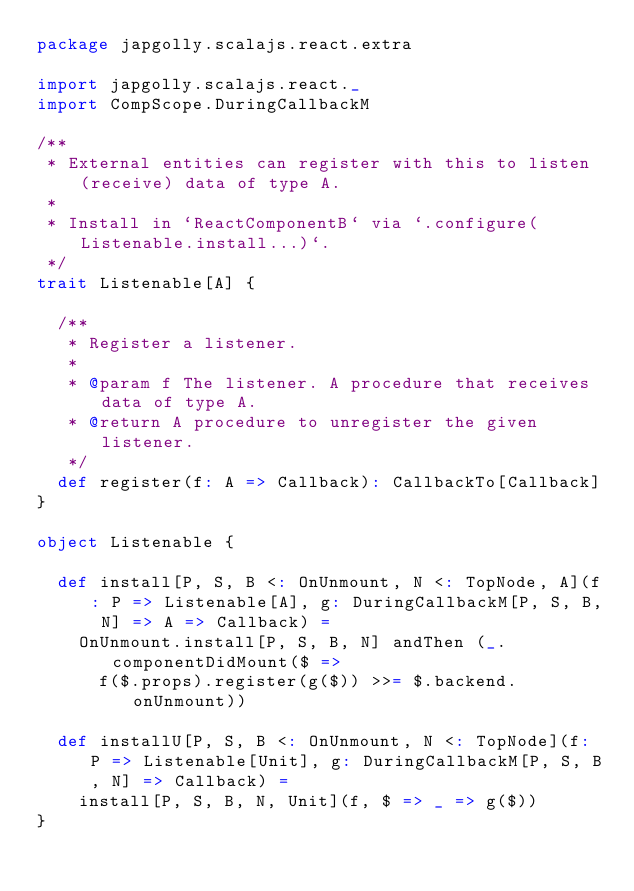Convert code to text. <code><loc_0><loc_0><loc_500><loc_500><_Scala_>package japgolly.scalajs.react.extra

import japgolly.scalajs.react._
import CompScope.DuringCallbackM

/**
 * External entities can register with this to listen (receive) data of type A.
 *
 * Install in `ReactComponentB` via `.configure(Listenable.install...)`.
 */
trait Listenable[A] {

  /**
   * Register a listener.
   *
   * @param f The listener. A procedure that receives data of type A.
   * @return A procedure to unregister the given listener.
   */
  def register(f: A => Callback): CallbackTo[Callback]
}

object Listenable {

  def install[P, S, B <: OnUnmount, N <: TopNode, A](f: P => Listenable[A], g: DuringCallbackM[P, S, B, N] => A => Callback) =
    OnUnmount.install[P, S, B, N] andThen (_.componentDidMount($ =>
      f($.props).register(g($)) >>= $.backend.onUnmount))

  def installU[P, S, B <: OnUnmount, N <: TopNode](f: P => Listenable[Unit], g: DuringCallbackM[P, S, B, N] => Callback) =
    install[P, S, B, N, Unit](f, $ => _ => g($))
}
</code> 